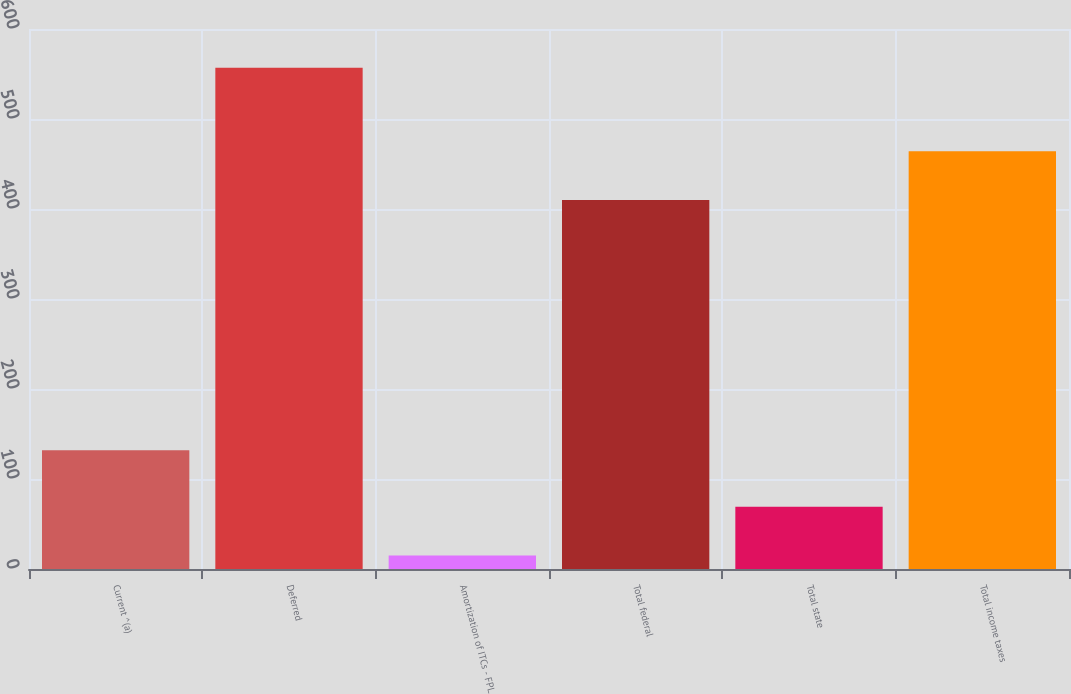Convert chart to OTSL. <chart><loc_0><loc_0><loc_500><loc_500><bar_chart><fcel>Current ^(a)<fcel>Deferred<fcel>Amortization of ITCs - FPL<fcel>Total federal<fcel>Total state<fcel>Total income taxes<nl><fcel>132<fcel>557<fcel>15<fcel>410<fcel>69.2<fcel>464.2<nl></chart> 